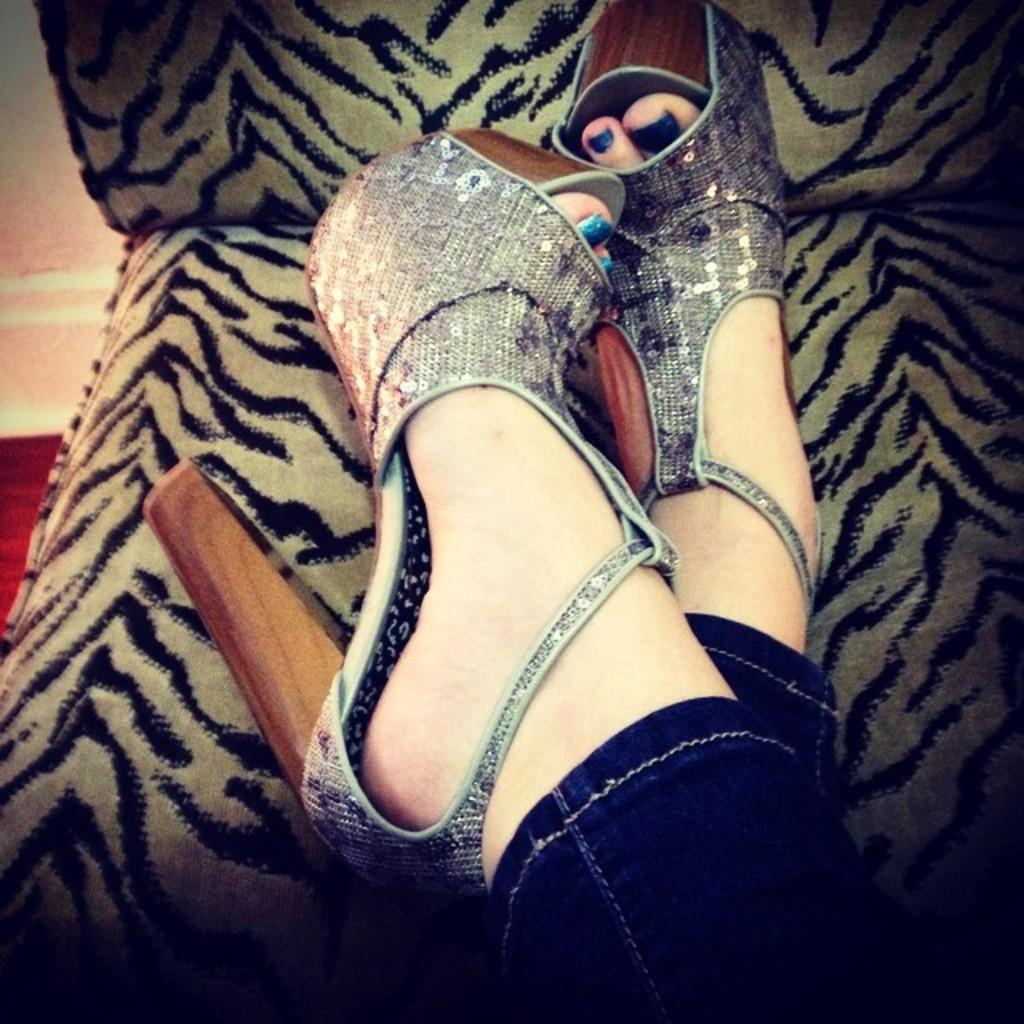What type of chair is in the image? There is a cream and black colored chair in the image. What is the position of the person in relation to the chair? A person's legs are on the chair. What can be seen on the person's feet? The person is wearing footwear. What can be seen in the background of the image? There is a wall and a floor visible in the background of the image. What organization does the person in the image represent? There is no information about an organization or any representation in the image. 